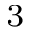Convert formula to latex. <formula><loc_0><loc_0><loc_500><loc_500>^ { 3 }</formula> 